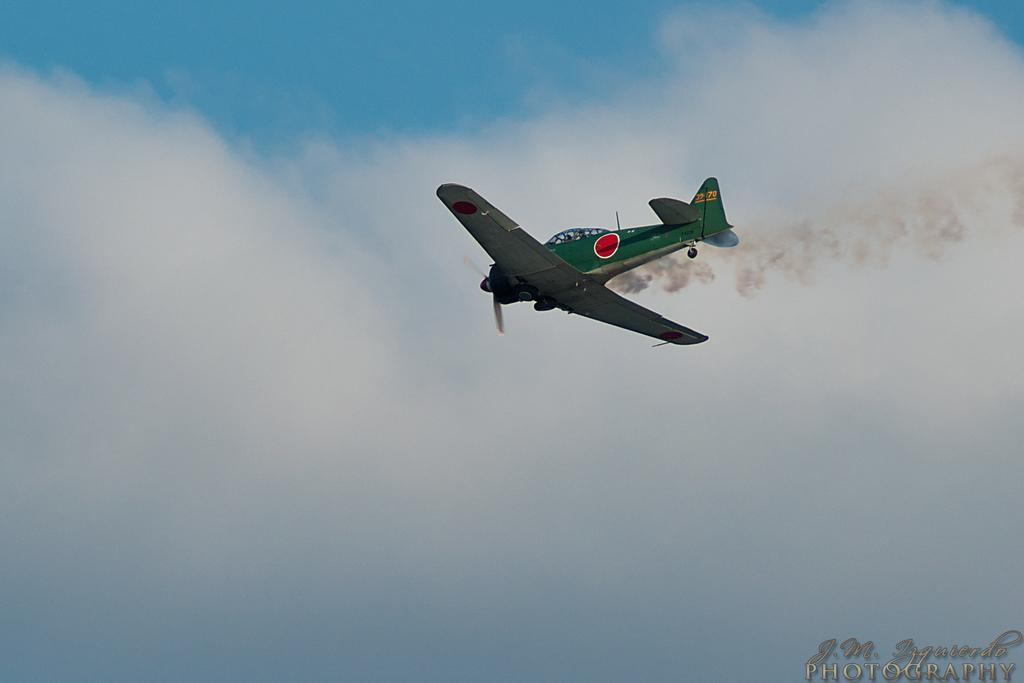What is the main subject of the image? The main subject of the image is an aircraft. What colors are used to paint the aircraft? The aircraft is in green, white, and red colors. Where is the aircraft located in the image? The aircraft is in the air. What can be seen in the background of the image? There are clouds and the sky visible in the background of the image. Can you see a town in the background of the image? No, there is no town visible in the background of the image; only clouds and the sky can be seen. Is there a squirrel sitting on the aircraft in the image? No, there is no squirrel present in the image; the main subject is the aircraft. 